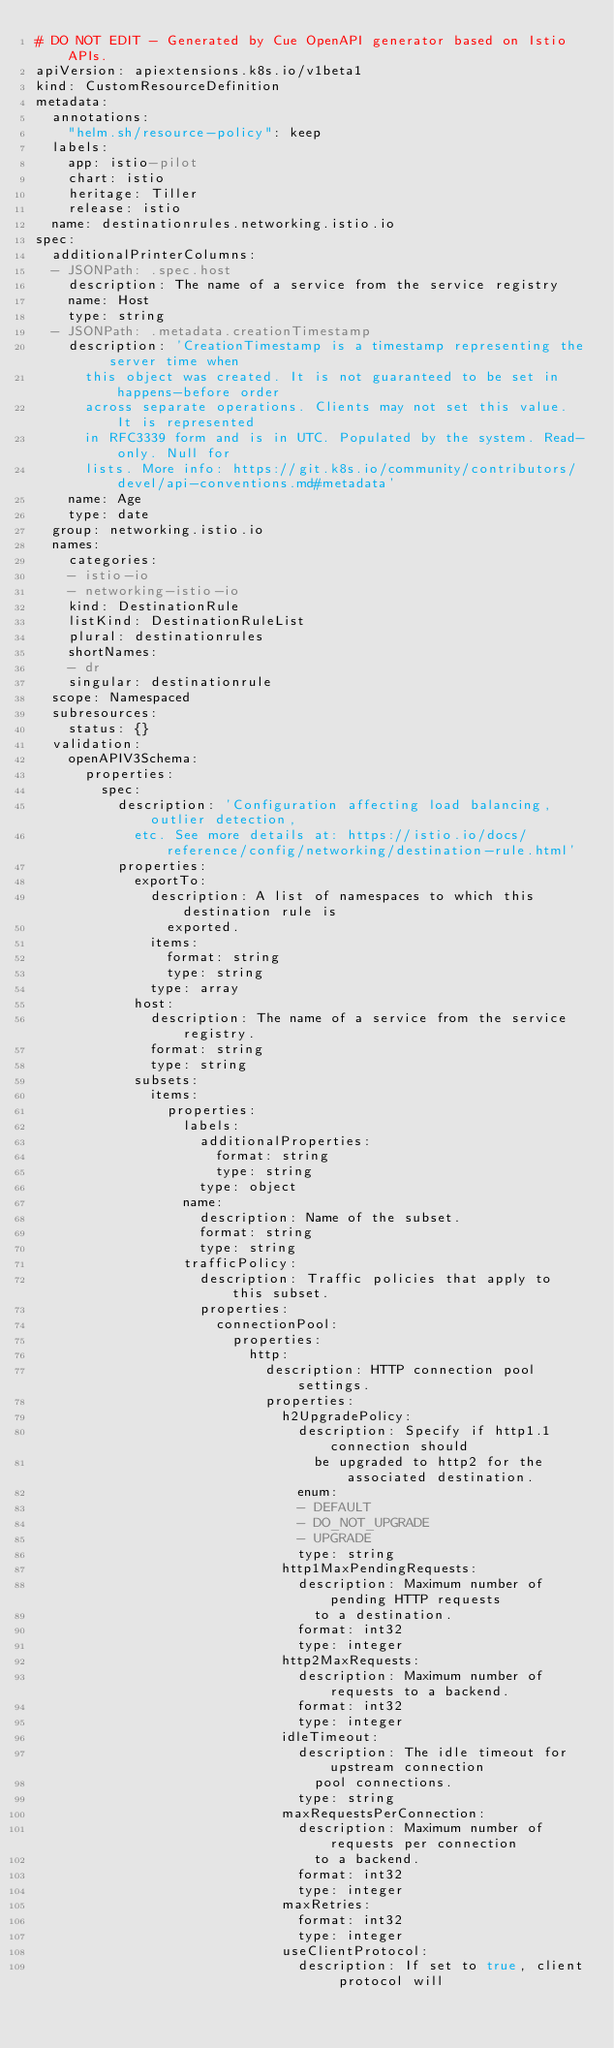Convert code to text. <code><loc_0><loc_0><loc_500><loc_500><_YAML_># DO NOT EDIT - Generated by Cue OpenAPI generator based on Istio APIs.
apiVersion: apiextensions.k8s.io/v1beta1
kind: CustomResourceDefinition
metadata:
  annotations:
    "helm.sh/resource-policy": keep
  labels:
    app: istio-pilot
    chart: istio
    heritage: Tiller
    release: istio
  name: destinationrules.networking.istio.io
spec:
  additionalPrinterColumns:
  - JSONPath: .spec.host
    description: The name of a service from the service registry
    name: Host
    type: string
  - JSONPath: .metadata.creationTimestamp
    description: 'CreationTimestamp is a timestamp representing the server time when
      this object was created. It is not guaranteed to be set in happens-before order
      across separate operations. Clients may not set this value. It is represented
      in RFC3339 form and is in UTC. Populated by the system. Read-only. Null for
      lists. More info: https://git.k8s.io/community/contributors/devel/api-conventions.md#metadata'
    name: Age
    type: date
  group: networking.istio.io
  names:
    categories:
    - istio-io
    - networking-istio-io
    kind: DestinationRule
    listKind: DestinationRuleList
    plural: destinationrules
    shortNames:
    - dr
    singular: destinationrule
  scope: Namespaced
  subresources:
    status: {}
  validation:
    openAPIV3Schema:
      properties:
        spec:
          description: 'Configuration affecting load balancing, outlier detection,
            etc. See more details at: https://istio.io/docs/reference/config/networking/destination-rule.html'
          properties:
            exportTo:
              description: A list of namespaces to which this destination rule is
                exported.
              items:
                format: string
                type: string
              type: array
            host:
              description: The name of a service from the service registry.
              format: string
              type: string
            subsets:
              items:
                properties:
                  labels:
                    additionalProperties:
                      format: string
                      type: string
                    type: object
                  name:
                    description: Name of the subset.
                    format: string
                    type: string
                  trafficPolicy:
                    description: Traffic policies that apply to this subset.
                    properties:
                      connectionPool:
                        properties:
                          http:
                            description: HTTP connection pool settings.
                            properties:
                              h2UpgradePolicy:
                                description: Specify if http1.1 connection should
                                  be upgraded to http2 for the associated destination.
                                enum:
                                - DEFAULT
                                - DO_NOT_UPGRADE
                                - UPGRADE
                                type: string
                              http1MaxPendingRequests:
                                description: Maximum number of pending HTTP requests
                                  to a destination.
                                format: int32
                                type: integer
                              http2MaxRequests:
                                description: Maximum number of requests to a backend.
                                format: int32
                                type: integer
                              idleTimeout:
                                description: The idle timeout for upstream connection
                                  pool connections.
                                type: string
                              maxRequestsPerConnection:
                                description: Maximum number of requests per connection
                                  to a backend.
                                format: int32
                                type: integer
                              maxRetries:
                                format: int32
                                type: integer
                              useClientProtocol:
                                description: If set to true, client protocol will</code> 